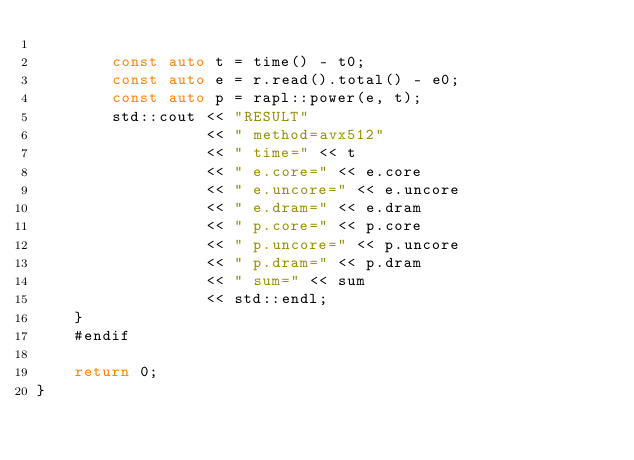Convert code to text. <code><loc_0><loc_0><loc_500><loc_500><_C++_>
        const auto t = time() - t0;
        const auto e = r.read().total() - e0;
        const auto p = rapl::power(e, t);
        std::cout << "RESULT"
                  << " method=avx512"
                  << " time=" << t
                  << " e.core=" << e.core
                  << " e.uncore=" << e.uncore
                  << " e.dram=" << e.dram
                  << " p.core=" << p.core
                  << " p.uncore=" << p.uncore
                  << " p.dram=" << p.dram
                  << " sum=" << sum
                  << std::endl;
    }
    #endif

    return 0;
}
</code> 